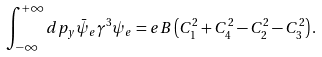<formula> <loc_0><loc_0><loc_500><loc_500>\int _ { - \infty } ^ { + \infty } d p _ { y } \bar { \psi } _ { e } \gamma ^ { 3 } \psi _ { e } = e B \left ( C _ { 1 } ^ { 2 } + C _ { 4 } ^ { 2 } - C _ { 2 } ^ { 2 } - C _ { 3 } ^ { 2 } \right ) .</formula> 